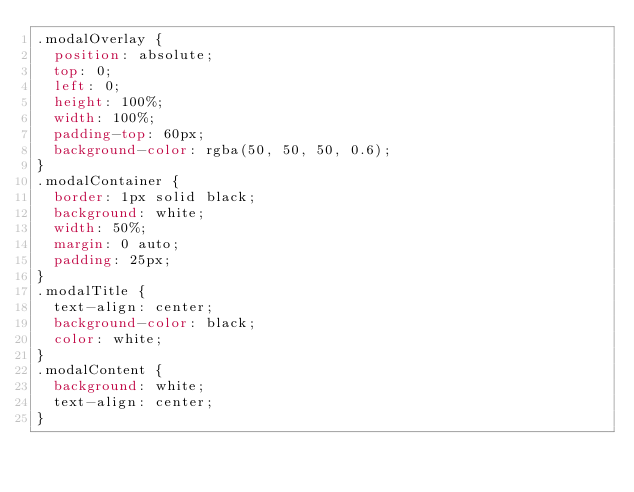<code> <loc_0><loc_0><loc_500><loc_500><_CSS_>.modalOverlay {
  position: absolute;
  top: 0;
  left: 0;
  height: 100%;
  width: 100%;
  padding-top: 60px;
  background-color: rgba(50, 50, 50, 0.6);
}
.modalContainer {
  border: 1px solid black;
  background: white;
  width: 50%;
  margin: 0 auto;
  padding: 25px;
}
.modalTitle {
  text-align: center;
  background-color: black;
  color: white;
}
.modalContent {
  background: white;
  text-align: center;
}
</code> 